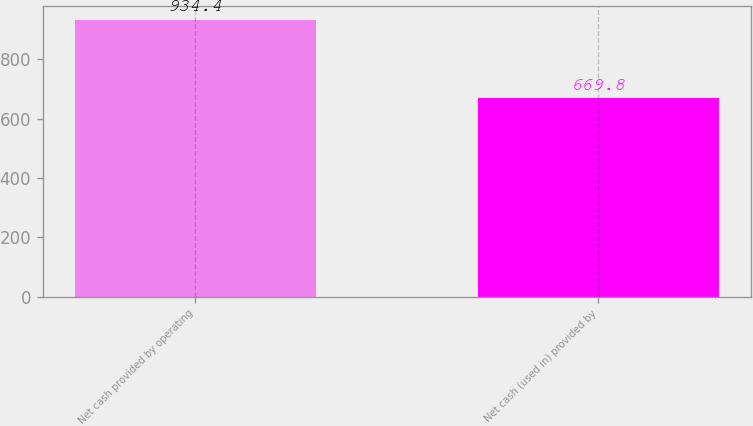<chart> <loc_0><loc_0><loc_500><loc_500><bar_chart><fcel>Net cash provided by operating<fcel>Net cash (used in) provided by<nl><fcel>934.4<fcel>669.8<nl></chart> 